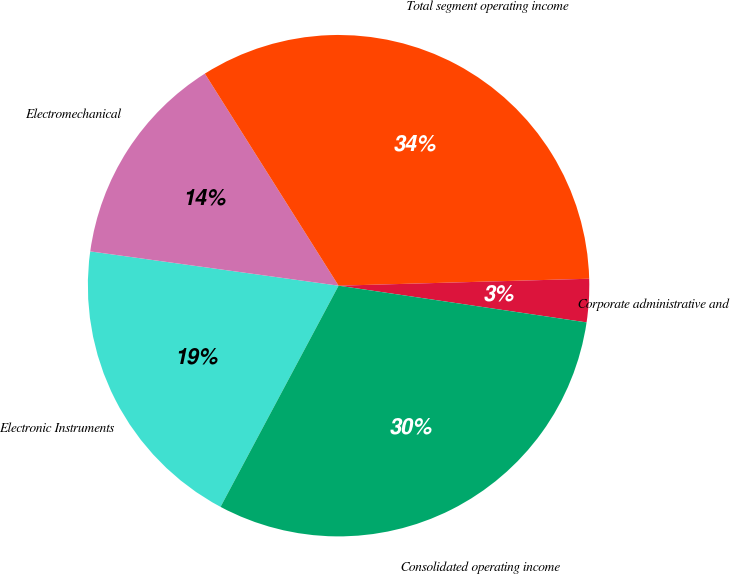Convert chart to OTSL. <chart><loc_0><loc_0><loc_500><loc_500><pie_chart><fcel>Electronic Instruments<fcel>Electromechanical<fcel>Total segment operating income<fcel>Corporate administrative and<fcel>Consolidated operating income<nl><fcel>19.38%<fcel>13.86%<fcel>33.51%<fcel>2.78%<fcel>30.46%<nl></chart> 